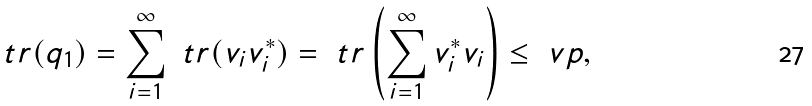<formula> <loc_0><loc_0><loc_500><loc_500>\ t r ( q _ { 1 } ) = \sum ^ { \infty } _ { i = 1 } \ t r ( v _ { i } v ^ { * } _ { i } ) = \ t r \left ( \sum ^ { \infty } _ { i = 1 } v ^ { * } _ { i } v _ { i } \right ) \leq \ v p ,</formula> 